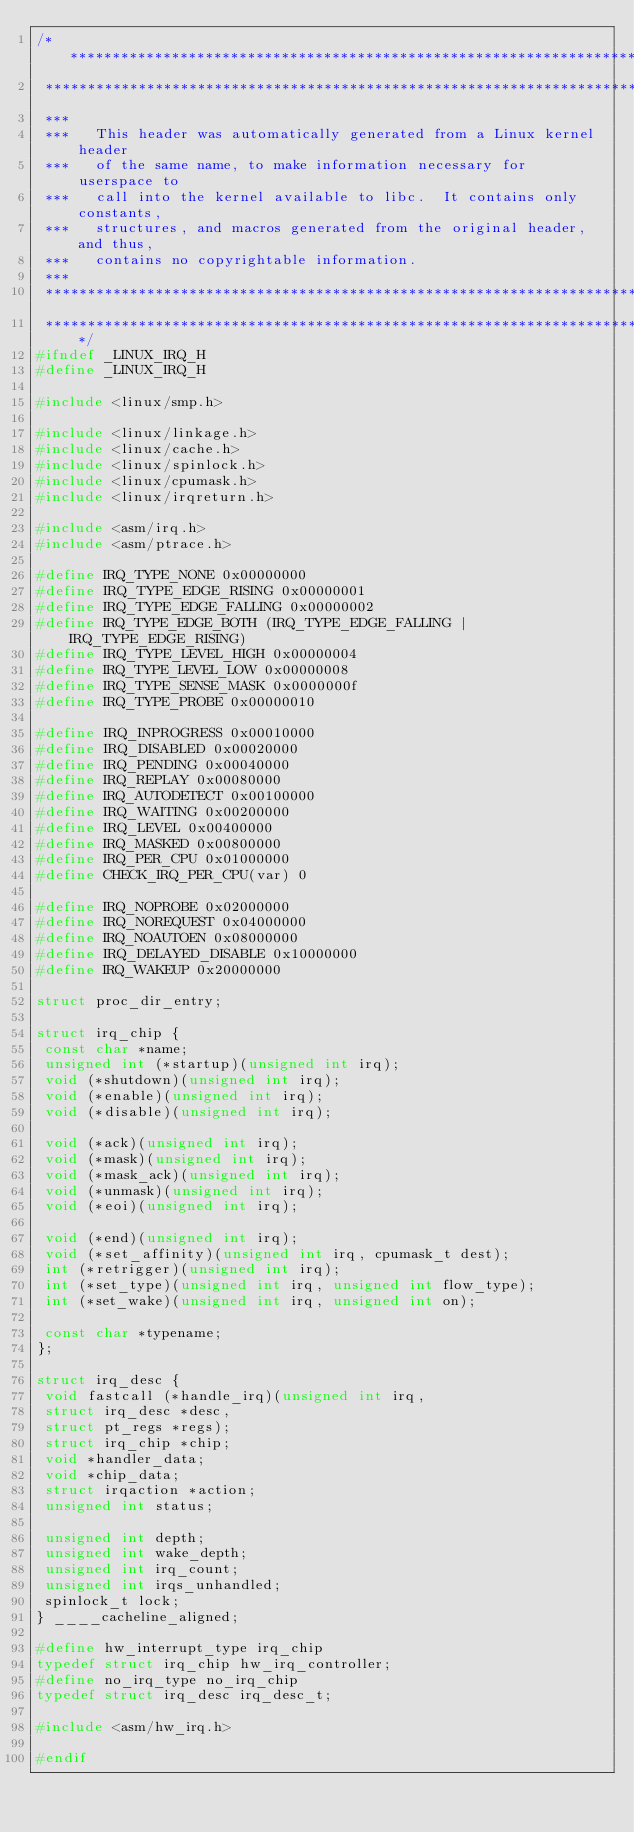Convert code to text. <code><loc_0><loc_0><loc_500><loc_500><_C_>/****************************************************************************
 ****************************************************************************
 ***
 ***   This header was automatically generated from a Linux kernel header
 ***   of the same name, to make information necessary for userspace to
 ***   call into the kernel available to libc.  It contains only constants,
 ***   structures, and macros generated from the original header, and thus,
 ***   contains no copyrightable information.
 ***
 ****************************************************************************
 ****************************************************************************/
#ifndef _LINUX_IRQ_H
#define _LINUX_IRQ_H

#include <linux/smp.h>

#include <linux/linkage.h>
#include <linux/cache.h>
#include <linux/spinlock.h>
#include <linux/cpumask.h>
#include <linux/irqreturn.h>

#include <asm/irq.h>
#include <asm/ptrace.h>

#define IRQ_TYPE_NONE 0x00000000  
#define IRQ_TYPE_EDGE_RISING 0x00000001  
#define IRQ_TYPE_EDGE_FALLING 0x00000002  
#define IRQ_TYPE_EDGE_BOTH (IRQ_TYPE_EDGE_FALLING | IRQ_TYPE_EDGE_RISING)
#define IRQ_TYPE_LEVEL_HIGH 0x00000004  
#define IRQ_TYPE_LEVEL_LOW 0x00000008  
#define IRQ_TYPE_SENSE_MASK 0x0000000f  
#define IRQ_TYPE_PROBE 0x00000010  

#define IRQ_INPROGRESS 0x00010000  
#define IRQ_DISABLED 0x00020000  
#define IRQ_PENDING 0x00040000  
#define IRQ_REPLAY 0x00080000  
#define IRQ_AUTODETECT 0x00100000  
#define IRQ_WAITING 0x00200000  
#define IRQ_LEVEL 0x00400000  
#define IRQ_MASKED 0x00800000  
#define IRQ_PER_CPU 0x01000000  
#define CHECK_IRQ_PER_CPU(var) 0

#define IRQ_NOPROBE 0x02000000  
#define IRQ_NOREQUEST 0x04000000  
#define IRQ_NOAUTOEN 0x08000000  
#define IRQ_DELAYED_DISABLE 0x10000000  
#define IRQ_WAKEUP 0x20000000  

struct proc_dir_entry;

struct irq_chip {
 const char *name;
 unsigned int (*startup)(unsigned int irq);
 void (*shutdown)(unsigned int irq);
 void (*enable)(unsigned int irq);
 void (*disable)(unsigned int irq);

 void (*ack)(unsigned int irq);
 void (*mask)(unsigned int irq);
 void (*mask_ack)(unsigned int irq);
 void (*unmask)(unsigned int irq);
 void (*eoi)(unsigned int irq);

 void (*end)(unsigned int irq);
 void (*set_affinity)(unsigned int irq, cpumask_t dest);
 int (*retrigger)(unsigned int irq);
 int (*set_type)(unsigned int irq, unsigned int flow_type);
 int (*set_wake)(unsigned int irq, unsigned int on);

 const char *typename;
};

struct irq_desc {
 void fastcall (*handle_irq)(unsigned int irq,
 struct irq_desc *desc,
 struct pt_regs *regs);
 struct irq_chip *chip;
 void *handler_data;
 void *chip_data;
 struct irqaction *action;
 unsigned int status;

 unsigned int depth;
 unsigned int wake_depth;
 unsigned int irq_count;
 unsigned int irqs_unhandled;
 spinlock_t lock;
} ____cacheline_aligned;

#define hw_interrupt_type irq_chip
typedef struct irq_chip hw_irq_controller;
#define no_irq_type no_irq_chip
typedef struct irq_desc irq_desc_t;

#include <asm/hw_irq.h>

#endif
</code> 